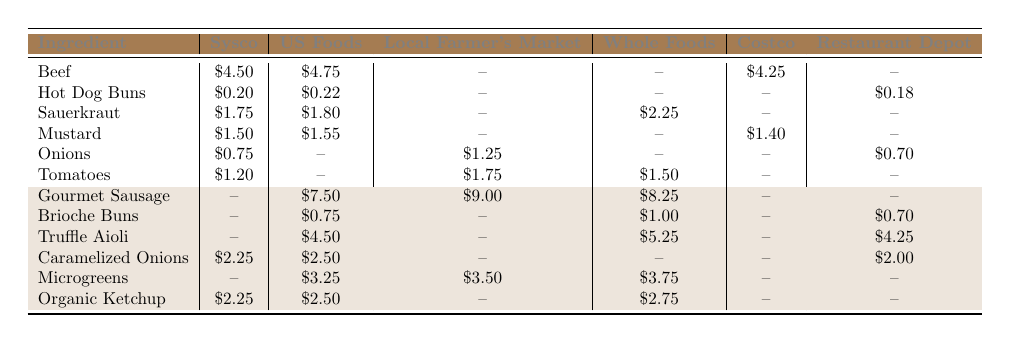What is the lowest cost for Hot Dog Buns from any supplier? The table shows the costs for Hot Dog Buns across different suppliers: Sysco ($0.20), US Foods ($0.22), and Restaurant Depot ($0.18). Comparing these values, Restaurant Depot has the lowest cost at $0.18.
Answer: $0.18 Which ingredient has the highest cost from US Foods? By examining the table, the costs from US Foods for each ingredient are as follows: Gourmet Sausage ($7.50), Sauerkraut ($1.80), Mustard ($1.55), etc. The highest cost among these is for Gourmet Sausage at $7.50.
Answer: Gourmet Sausage Is there a supplier that provides Gourmet Sausage at the same price as Whole Foods? Looking at the table, Whole Foods offers Gourmet Sausage at $8.25, and checking the other suppliers, US Foods offers it at $7.50 and the Local Farmer's Market at $9.00. Since no other supplier provides Gourmet Sausage at $8.25, the answer is no.
Answer: No What is the average cost of Onions from available suppliers? The costs for Onions are: Sysco ($0.75), Local Farmer's Market ($1.25), and Restaurant Depot ($0.70). To get the average, we sum these costs: $0.75 + $1.25 + $0.70 = $2.70. Then we divide by the number of suppliers (3): $2.70 / 3 = $0.90.
Answer: $0.90 Which supplier offers the most ingredients for sourcing based on the table? By reviewing the table, we count the number of ingredients each supplier provides: Sysco (6), US Foods (5), Local Farmer's Market (3), Whole Foods (4), Costco (2), and Restaurant Depot (4). Sysco provides the most ingredients at 6.
Answer: Sysco What is the total cost of purchasing one unit of each ingredient from Sysco? We find the costs for all ingredients supplied by Sysco: Beef ($4.50), Hot Dog Buns ($0.20), Sauerkraut ($1.75), Mustard ($1.50), Onions ($0.75), Tomatoes ($1.20), and Caramelized Onions ($2.25). Adding these values gives: $4.50 + $0.20 + $1.75 + $1.50 + $0.75 + $1.20 + $2.25 = $12.15.
Answer: $12.15 Which item is cheaper at Costco compared to the other suppliers? Evaluating the table, the items available from Costco are Beef ($4.25) and Mustard ($1.40). We compare these prices with other suppliers. Beef is cheaper than US Foods and Sysco but more expensive than Whole Foods, and Mustard is cheaper than US Foods (1.55). Thus, Mustard is the single item confirmed cheaper overall.
Answer: Mustard If a chef orders 10 units of Organic Ketchup from Whole Foods, what will be the total cost? Whole Foods offers Organic Ketchup at $2.75 per unit. Multiplying the cost per unit by 10 gives: $2.75 * 10 = $27.50.
Answer: $27.50 